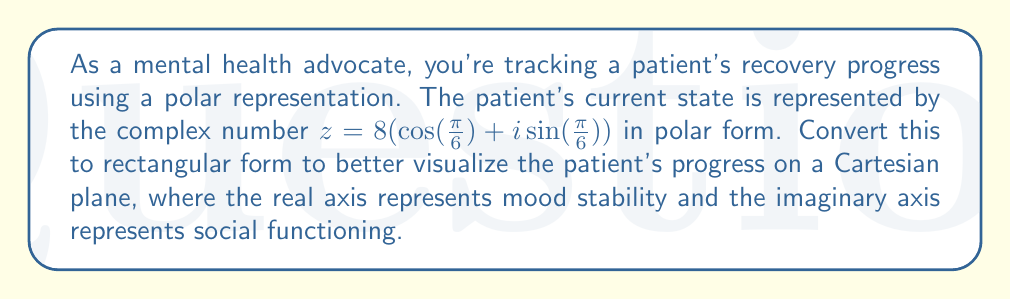Can you solve this math problem? To convert a complex number from polar form to rectangular form, we use the following steps:

1) The general form of a complex number in polar form is:
   $z = r(\cos(\theta) + i\sin(\theta))$

   Where $r$ is the magnitude and $\theta$ is the angle.

2) In this case, $r = 8$ and $\theta = \frac{\pi}{6}$

3) To convert to rectangular form $(a + bi)$, we use these formulas:
   $a = r\cos(\theta)$
   $b = r\sin(\theta)$

4) Let's calculate $a$:
   $a = 8\cos(\frac{\pi}{6})$
   $\cos(\frac{\pi}{6}) = \frac{\sqrt{3}}{2}$
   $a = 8 \cdot \frac{\sqrt{3}}{2} = 4\sqrt{3}$

5) Now let's calculate $b$:
   $b = 8\sin(\frac{\pi}{6})$
   $\sin(\frac{\pi}{6}) = \frac{1}{2}$
   $b = 8 \cdot \frac{1}{2} = 4$

6) Therefore, in rectangular form, $z = 4\sqrt{3} + 4i$

This means the patient's mood stability (real part) is at $4\sqrt{3}$ units, and their social functioning (imaginary part) is at 4 units on our scale.
Answer: $z = 4\sqrt{3} + 4i$ 